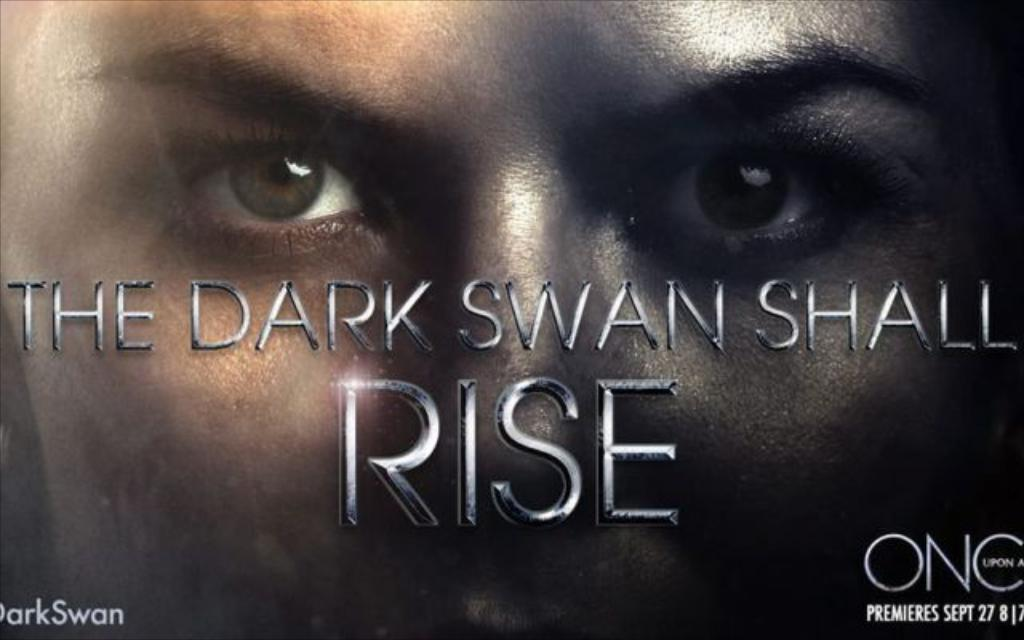What is featured in the image? There is a poster in the image. What can be seen on the poster? The poster has a person's face on it. Are there any words on the poster? Yes, there is text on the poster. How many trees are visible in the image? There are no trees visible in the image; it only features a poster with a person's face and text. 